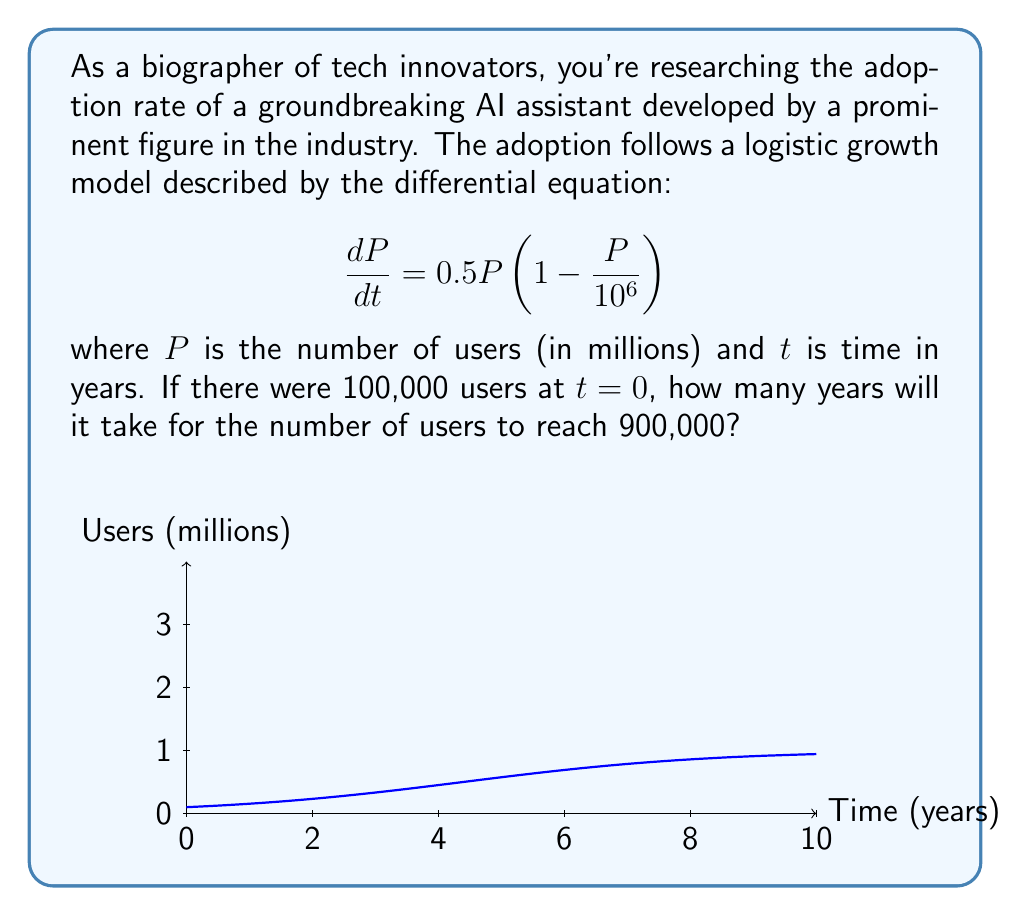Give your solution to this math problem. To solve this problem, we need to use the logistic growth model and integrate the differential equation. Let's proceed step-by-step:

1) The logistic growth model is given by:
   $$\frac{dP}{dt} = rP(1 - \frac{P}{K})$$
   where $r$ is the growth rate and $K$ is the carrying capacity.

2) In our case, $r = 0.5$ and $K = 10^6$ (1 million users).

3) The solution to this differential equation is:
   $$P(t) = \frac{K}{1 + Ce^{-rt}}$$
   where $C$ is a constant determined by the initial condition.

4) At $t=0$, $P(0) = 100,000 = 0.1$ million. Let's substitute this:
   $$0.1 = \frac{1}{1 + C}$$

5) Solving for $C$:
   $$C = \frac{1-0.1}{0.1} = 9$$

6) Now our equation is:
   $$P(t) = \frac{1}{1 + 9e^{-0.5t}}$$

7) We want to find $t$ when $P(t) = 900,000 = 0.9$ million:
   $$0.9 = \frac{1}{1 + 9e^{-0.5t}}$$

8) Solving for $t$:
   $$1 + 9e^{-0.5t} = \frac{1}{0.9}$$
   $$9e^{-0.5t} = \frac{1}{0.9} - 1 = \frac{1}{9}$$
   $$e^{-0.5t} = \frac{1}{81}$$
   $$-0.5t = \ln(\frac{1}{81}) = -\ln(81)$$
   $$t = \frac{2\ln(81)}{0.5} = 4\ln(81) \approx 17.61$$

Therefore, it will take approximately 17.61 years for the number of users to reach 900,000.
Answer: 17.61 years 